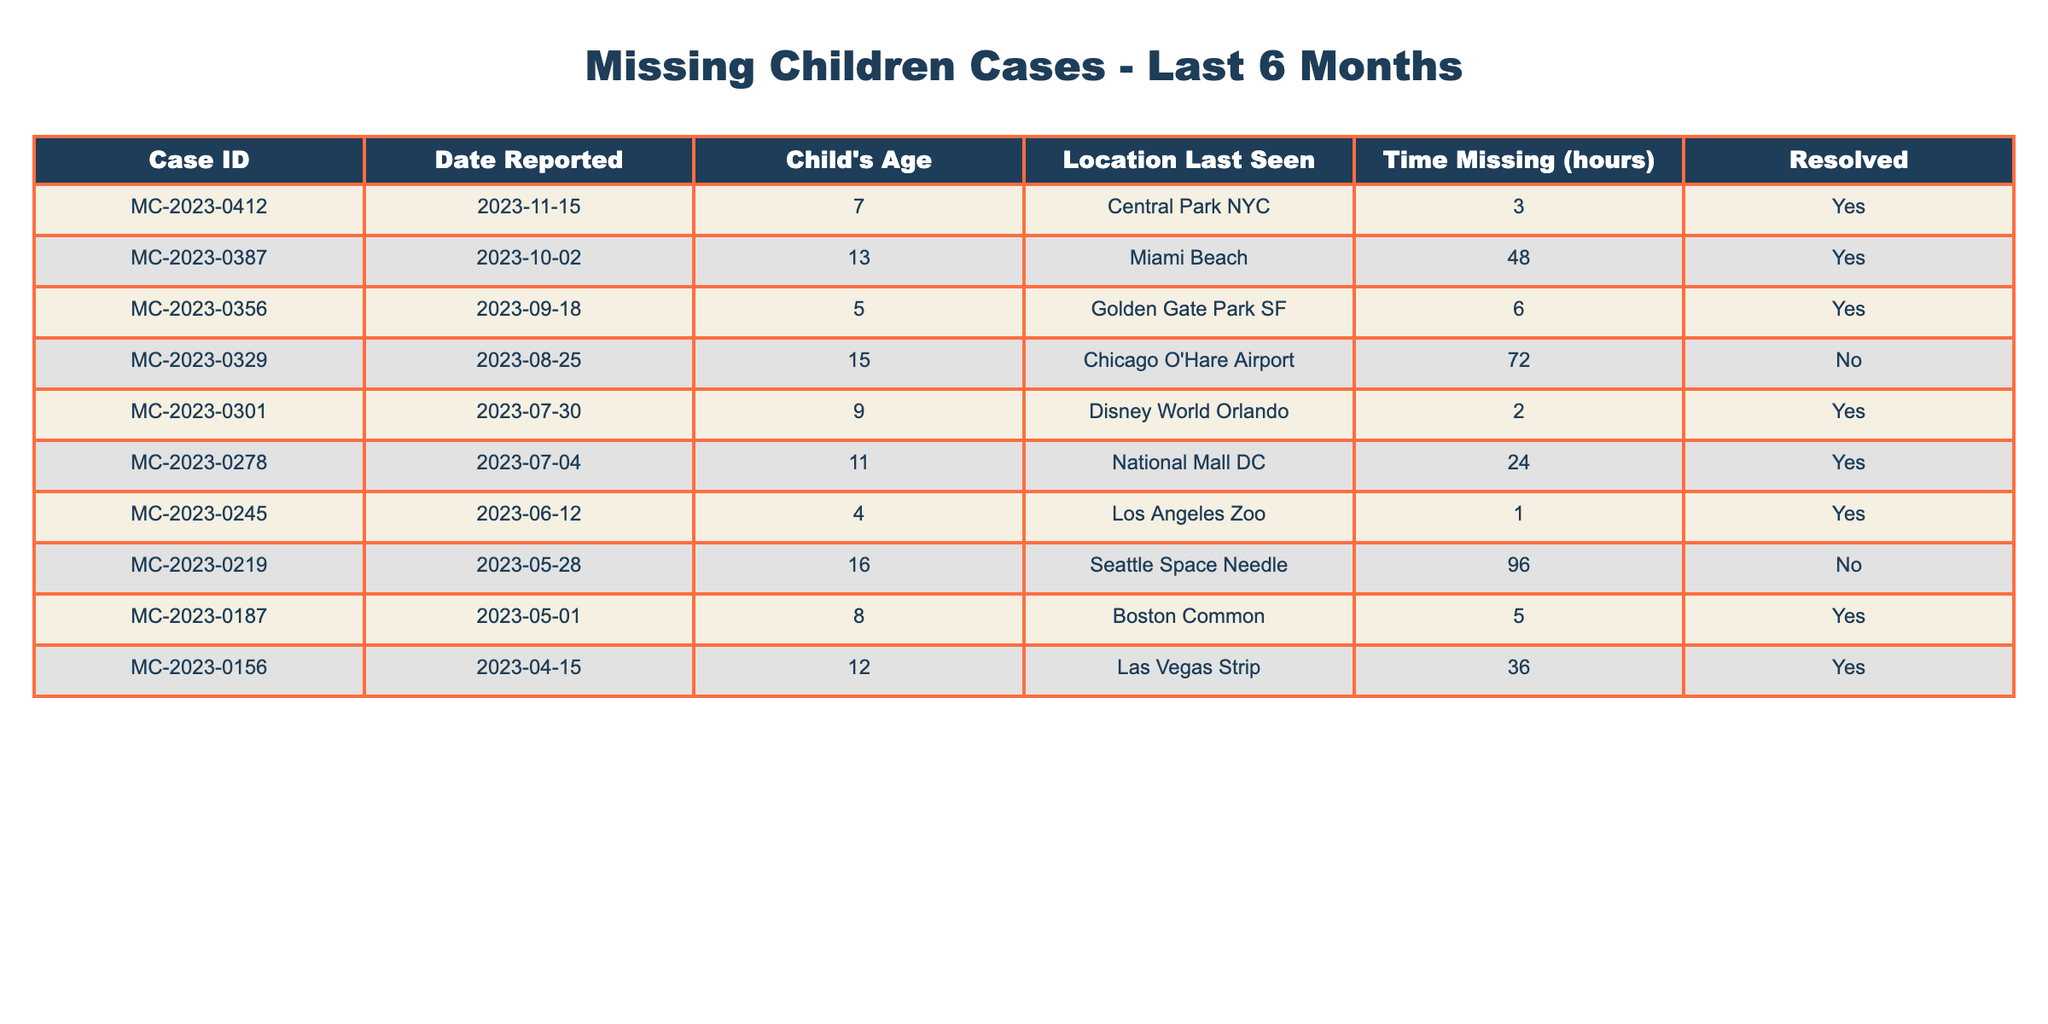What is the youngest child's age in the table? The table displays a column specifically for the child's age. The ages listed are 7, 13, 5, 15, 9, 11, 4, 16, 8, 12. Among these values, the smallest is 4.
Answer: 4 How many cases were reported for children aged 12 and older? By reviewing the table, we need to count the instances where the child's age is 12 or older. The ages meeting this criterion are 13, 15, 16, and 12, leading to a total of 4 cases.
Answer: 4 What is the total number of unresolved cases? The resolved status is indicated in the table for each case. The unresolved cases are those marked as "No." There are 2 such cases (MC-2023-0329 and MC-2023-0219).
Answer: 2 Which case had the longest time missing and what was the resolution status? The longest time missing is 96 hours, corresponding to the case MC-2023-0219. Referring to the resolution status column, this case remains unresolved as indicated by "No."
Answer: MC-2023-0219, No How many children were missing for more than 24 hours? We will sum the cases where the "Time Missing" exceeds 24 hours. The qualifying values are 48, 72, and 96 hours, thus three cases in total qualifies.
Answer: 3 Was there any case reported in Central Park NYC? We can find Central Park NYC listed under "Location Last Seen." Checking all entries, only one case (MC-2023-0412) fits this location and is marked as resolved.
Answer: Yes What is the average age of children in the reported cases? First, we need to calculate the total sum of ages, which equals 7 + 13 + 5 + 15 + 9 + 11 + 4 + 16 + 8 + 12 = 100. Then, we divide this sum by the total number of cases, which is 10. Thus, the average age is 100 / 10 = 10.
Answer: 10 How many cases were resolved within 10 hours? We will check the "Time Missing" and count only those cases that are less than or equal to 10 hours and resolved. The relevant cases are MC-2023-0412, MC-2023-0356, MC-2023-0301, and MC-2023-0187, summing up to 4 resolved cases in total.
Answer: 4 What were the ages of children in cases that remain unresolved? The unresolved cases in the table are MC-2023-0329 (15 years old) and MC-2023-0219 (16 years old). Therefore, the ages of children in unresolved cases are 15 and 16.
Answer: 15, 16 Which location had the highest number of resolved cases? We can check each location and count the resolved cases. Upon reviewing, Central Park and Disney World Orlando each had 1 case, Los Angeles Zoo had 1, National Mall DC had 1 (4 total). However, each of these locations has only one resolved case, while Miami Beach also has 1. Thus, each location ties in the highest count of resolved cases.
Answer: All resolved locations tie (1 case each) 